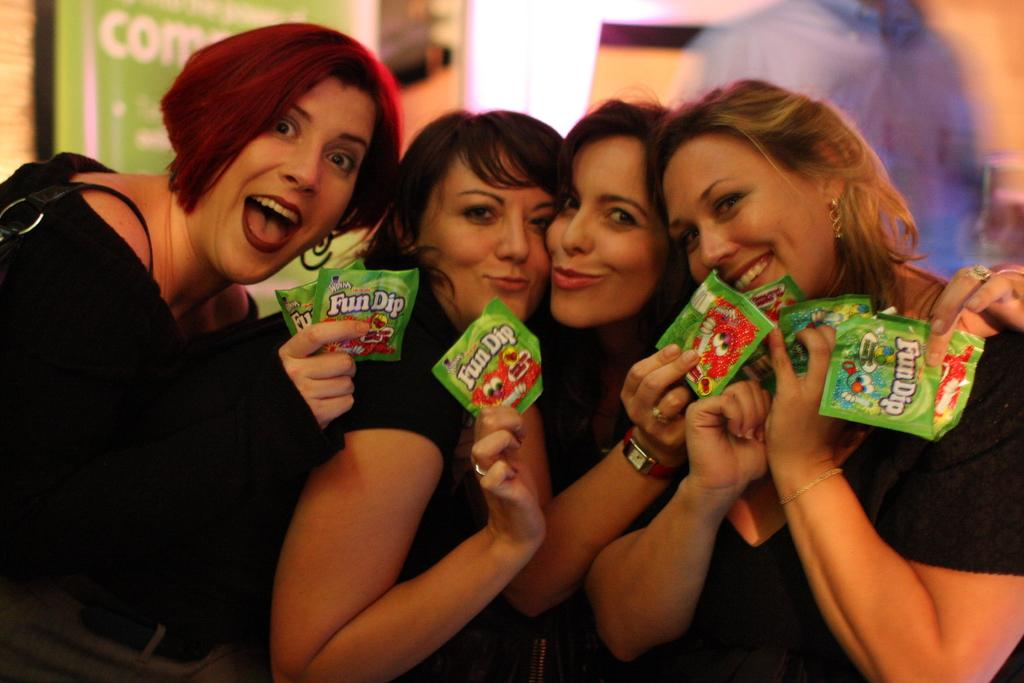What are the women in the image holding? The women in the image are holding packets. Can you describe the background of the image? There is a person and a board in the background of the image. How many sheep can be seen in the image? There are no sheep present in the image. Can you describe the fangs of the person in the background? There is no mention of fangs or any such feature on the person in the background of the image. 